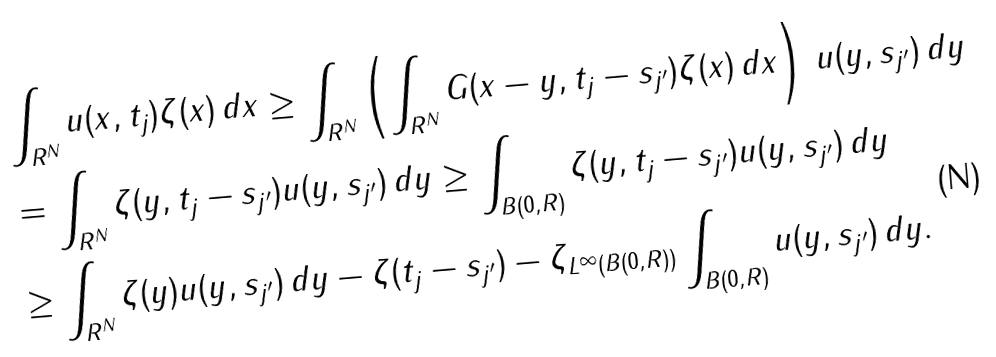<formula> <loc_0><loc_0><loc_500><loc_500>& \int _ { { R } ^ { N } } u ( x , t _ { j } ) \zeta ( x ) \, d x \geq \int _ { { R } ^ { N } } \left ( \int _ { { R } ^ { N } } G ( x - y , t _ { j } - s _ { j ^ { \prime } } ) \zeta ( x ) \, d x \right ) \, u ( y , s _ { j ^ { \prime } } ) \, d y \\ & = \int _ { { R } ^ { N } } \zeta ( y , t _ { j } - s _ { j ^ { \prime } } ) u ( y , s _ { j ^ { \prime } } ) \, d y \geq \int _ { B ( 0 , R ) } \zeta ( y , t _ { j } - s _ { j ^ { \prime } } ) u ( y , s _ { j ^ { \prime } } ) \, d y \\ & \geq \int _ { { R } ^ { N } } \zeta ( y ) u ( y , s _ { j ^ { \prime } } ) \, d y - \| \zeta ( t _ { j } - s _ { j ^ { \prime } } ) - \zeta \| _ { L ^ { \infty } ( B ( 0 , R ) ) } \int _ { B ( 0 , R ) } u ( y , s _ { j ^ { \prime } } ) \, d y .</formula> 